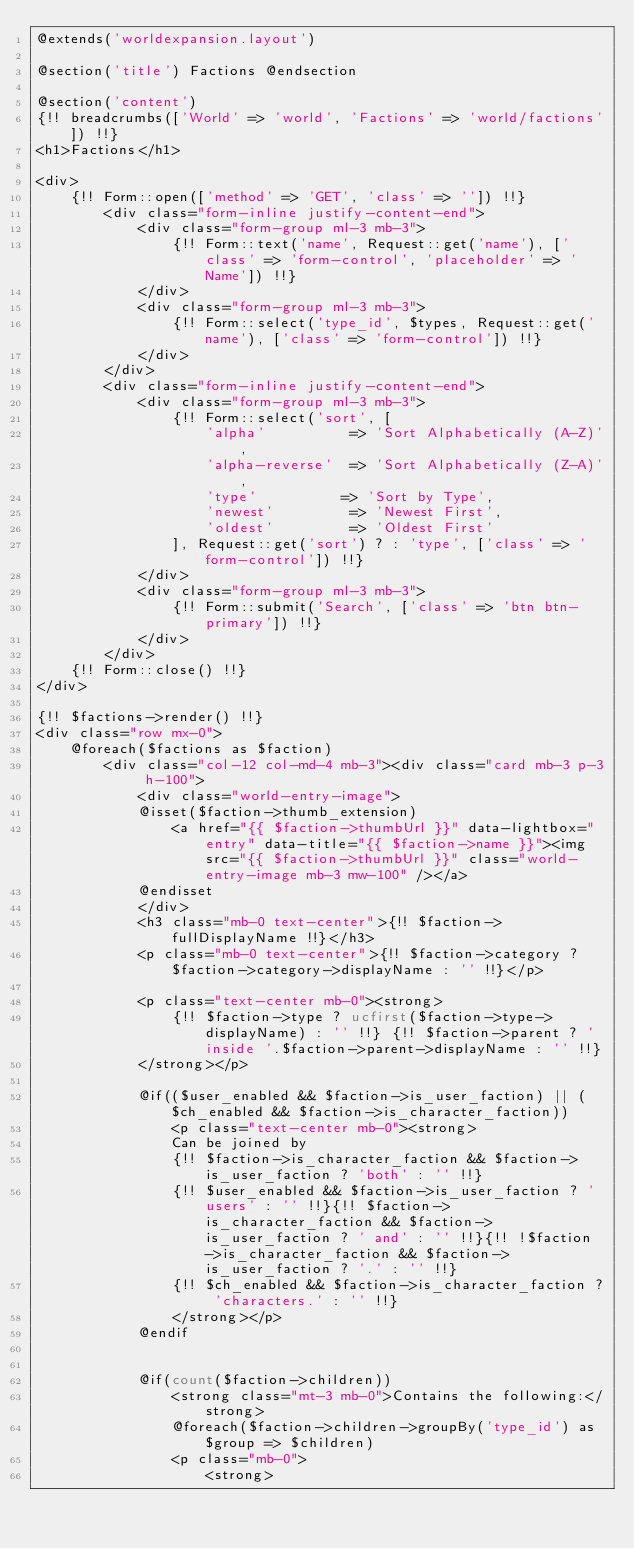Convert code to text. <code><loc_0><loc_0><loc_500><loc_500><_PHP_>@extends('worldexpansion.layout')

@section('title') Factions @endsection

@section('content')
{!! breadcrumbs(['World' => 'world', 'Factions' => 'world/factions']) !!}
<h1>Factions</h1>

<div>
    {!! Form::open(['method' => 'GET', 'class' => '']) !!}
        <div class="form-inline justify-content-end">
            <div class="form-group ml-3 mb-3">
                {!! Form::text('name', Request::get('name'), ['class' => 'form-control', 'placeholder' => 'Name']) !!}
            </div>
            <div class="form-group ml-3 mb-3">
                {!! Form::select('type_id', $types, Request::get('name'), ['class' => 'form-control']) !!}
            </div>
        </div>
        <div class="form-inline justify-content-end">
            <div class="form-group ml-3 mb-3">
                {!! Form::select('sort', [
                    'alpha'          => 'Sort Alphabetically (A-Z)',
                    'alpha-reverse'  => 'Sort Alphabetically (Z-A)',
                    'type'          => 'Sort by Type',
                    'newest'         => 'Newest First',
                    'oldest'         => 'Oldest First'
                ], Request::get('sort') ? : 'type', ['class' => 'form-control']) !!}
            </div>
            <div class="form-group ml-3 mb-3">
                {!! Form::submit('Search', ['class' => 'btn btn-primary']) !!}
            </div>
        </div>
    {!! Form::close() !!}
</div>

{!! $factions->render() !!}
<div class="row mx-0">
    @foreach($factions as $faction)
        <div class="col-12 col-md-4 mb-3"><div class="card mb-3 p-3 h-100">
            <div class="world-entry-image">
            @isset($faction->thumb_extension)
                <a href="{{ $faction->thumbUrl }}" data-lightbox="entry" data-title="{{ $faction->name }}"><img src="{{ $faction->thumbUrl }}" class="world-entry-image mb-3 mw-100" /></a>
            @endisset
            </div>
            <h3 class="mb-0 text-center">{!! $faction->fullDisplayName !!}</h3>
            <p class="mb-0 text-center">{!! $faction->category ? $faction->category->displayName : '' !!}</p>

            <p class="text-center mb-0"><strong>
                {!! $faction->type ? ucfirst($faction->type->displayName) : '' !!} {!! $faction->parent ? 'inside '.$faction->parent->displayName : '' !!}
            </strong></p>

            @if(($user_enabled && $faction->is_user_faction) || ($ch_enabled && $faction->is_character_faction))
                <p class="text-center mb-0"><strong>
                Can be joined by
                {!! $faction->is_character_faction && $faction->is_user_faction ? 'both' : '' !!}
                {!! $user_enabled && $faction->is_user_faction ? 'users' : '' !!}{!! $faction->is_character_faction && $faction->is_user_faction ? ' and' : '' !!}{!! !$faction->is_character_faction && $faction->is_user_faction ? '.' : '' !!}
                {!! $ch_enabled && $faction->is_character_faction ? 'characters.' : '' !!}
                </strong></p>
            @endif


            @if(count($faction->children))
                <strong class="mt-3 mb-0">Contains the following:</strong>
                @foreach($faction->children->groupBy('type_id') as $group => $children)
                <p class="mb-0">
                    <strong></code> 